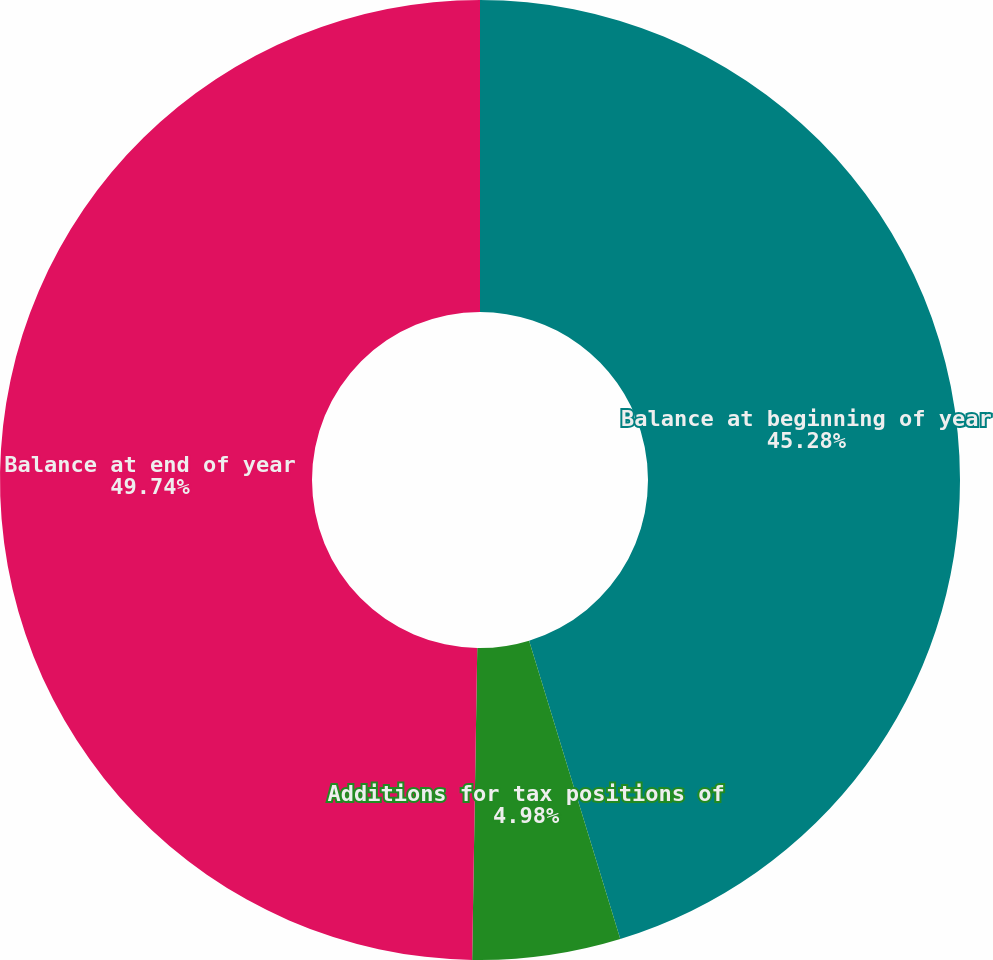Convert chart. <chart><loc_0><loc_0><loc_500><loc_500><pie_chart><fcel>Balance at beginning of year<fcel>Additions for tax positions of<fcel>Balance at end of year<nl><fcel>45.28%<fcel>4.98%<fcel>49.74%<nl></chart> 